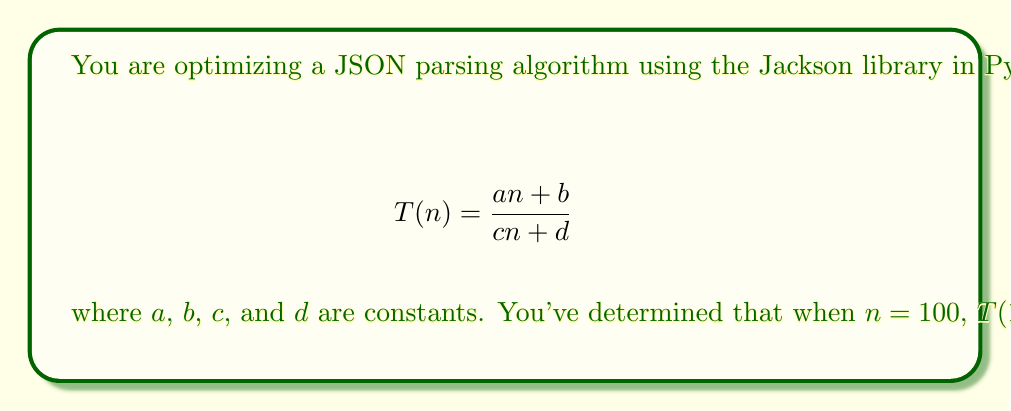Solve this math problem. Let's solve this step-by-step:

1) We have two equations based on the given information:

   For $n = 100$: $\frac{100a + b}{100c + d} = 2$
   For $n = 200$: $\frac{200a + b}{200c + d} = 1.5$

2) Let's simplify these equations:

   $100a + b = 2(100c + d)$
   $200a + b = 1.5(200c + d)$

3) Expand the right side:

   $100a + b = 200c + 2d$
   $200a + b = 300c + 1.5d$

4) Subtract the first equation from the second:

   $100a = 100c - 0.5d$

5) Simplify:

   $a = c - 0.005d$

6) Substitute this into the first equation:

   $100(c - 0.005d) + b = 200c + 2d$
   $100c - 0.5d + b = 200c + 2d$

7) Simplify:

   $b = 100c + 2.5d$

8) Now we have expressions for $a$ and $b$ in terms of $c$ and $d$. Let's substitute these into the original equation for $n = 100$:

   $\frac{100(c - 0.005d) + (100c + 2.5d)}{100c + d} = 2$

9) Simplify:

   $\frac{200c + 2d}{100c + d} = 2$

10) Cross multiply:

    $200c + 2d = 200c + 2d$

11) This is an identity, which means our equations are consistent. We can choose any values for $c$ and $d$ that make sense for our algorithm. Let's choose $c = 1$ and $d = 0$ for simplicity.

12) With $c = 1$ and $d = 0$, we can calculate $a$ and $b$:

    $a = c - 0.005d = 1 - 0 = 1$
    $b = 100c + 2.5d = 100 + 0 = 100$

Therefore, one possible solution is $a = 1$, $b = 100$, $c = 1$, and $d = 0$.
Answer: $a = 1$, $b = 100$, $c = 1$, $d = 0$ 